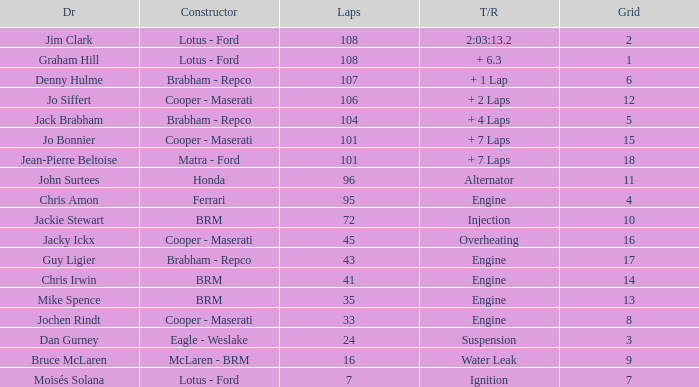What was the grid for suspension time/retired? 3.0. 